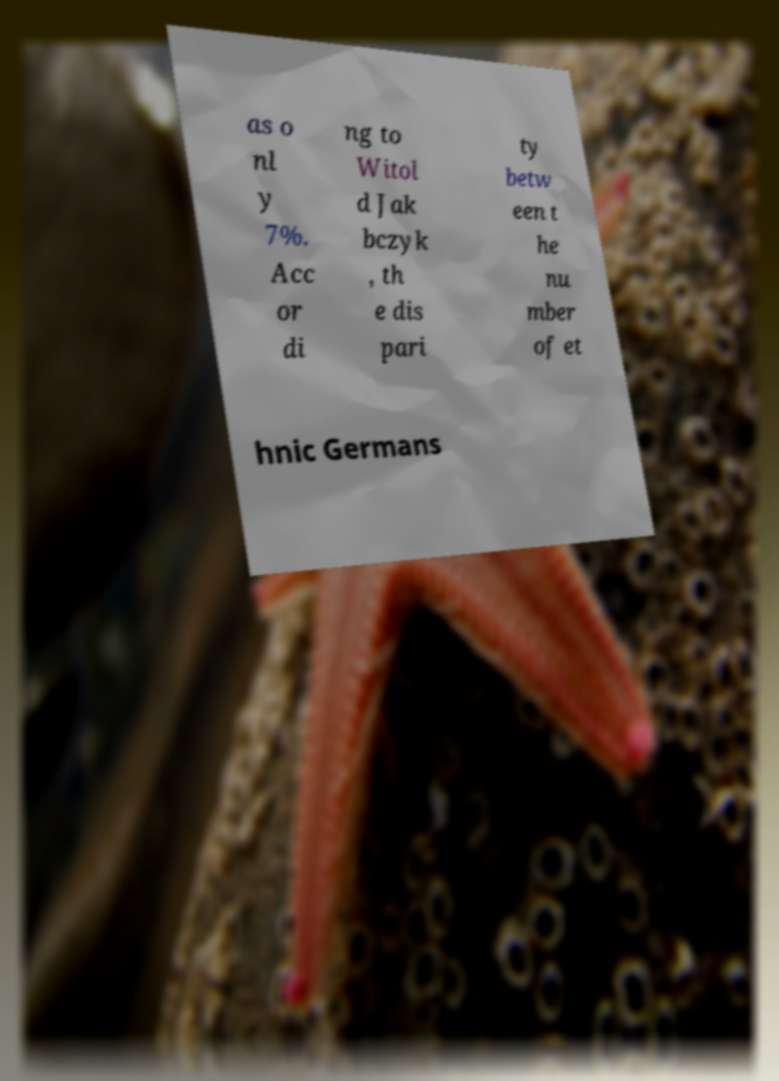Could you extract and type out the text from this image? as o nl y 7%. Acc or di ng to Witol d Jak bczyk , th e dis pari ty betw een t he nu mber of et hnic Germans 